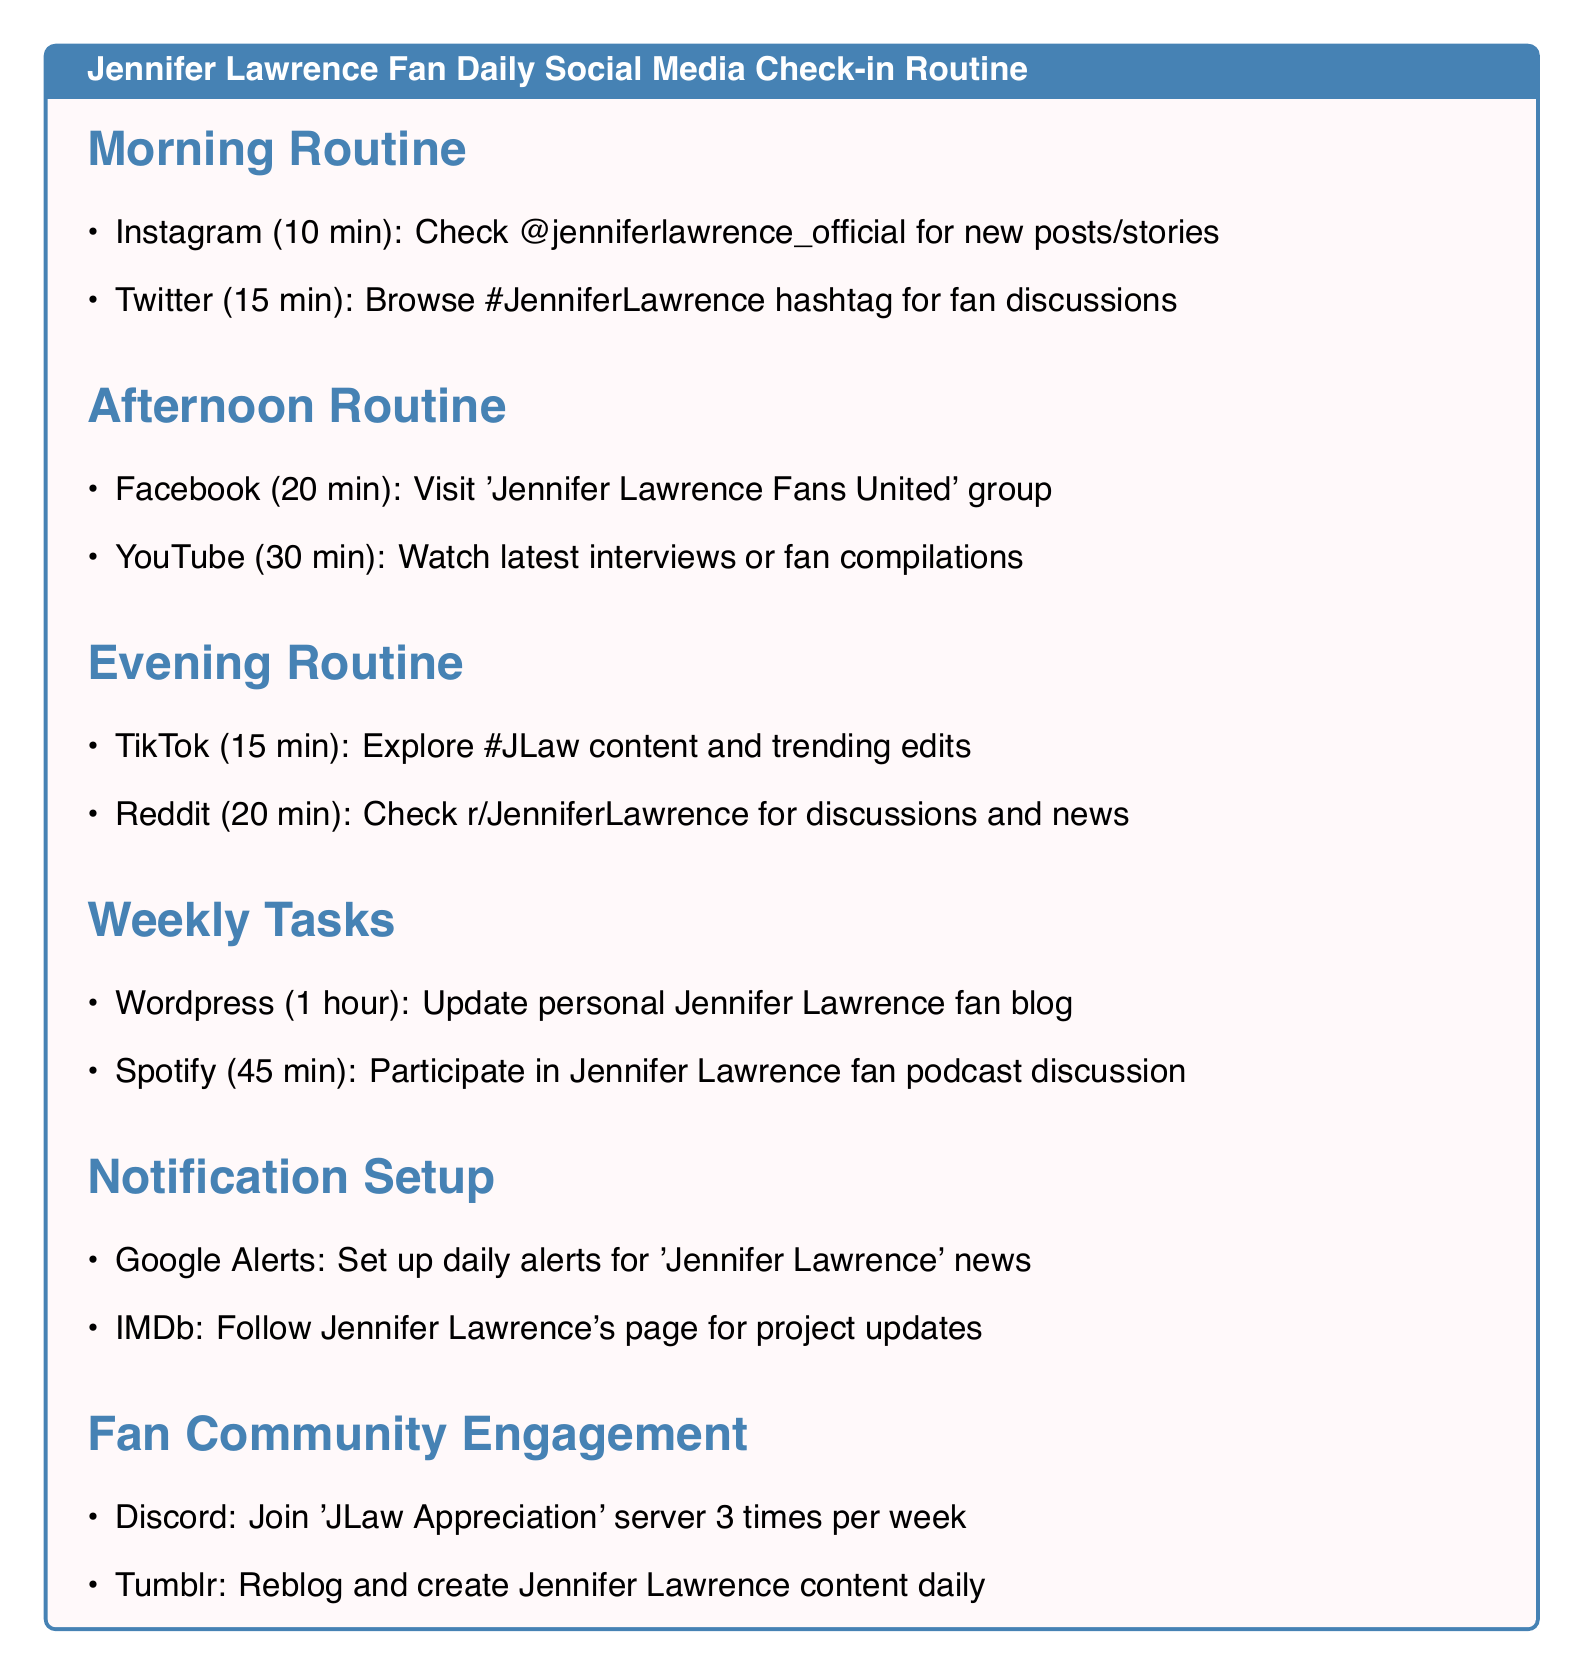what is the first platform checked in the morning routine? The document states that the first action in the morning routine is to check Instagram.
Answer: Instagram how many minutes are allocated to Twitter in the morning routine? The document lists 15 minutes for browsing Twitter in the morning routine.
Answer: 15 minutes which group on Facebook is recommended for updates? The document mentions visiting 'Jennifer Lawrence Fans United' group for updates.
Answer: 'Jennifer Lawrence Fans United' how long is spent watching content on YouTube in the afternoon routine? The afternoon routine specifies watching for 30 minutes on YouTube.
Answer: 30 minutes which social media platform is used to explore trending edits in the evening routine? The document indicates TikTok is used for exploring trending edits.
Answer: TikTok what is the total time spent on the afternoon routine? The afternoon routine consists of 20 minutes on Facebook and 30 minutes on YouTube, totaling 50 minutes.
Answer: 50 minutes how often should alerts be set up for 'Jennifer Lawrence' news articles? The document states these alerts should be set up daily.
Answer: Daily how many times a week is engagement on Discord suggested? The document indicates to join Discord 3 times per week.
Answer: 3 times per week what is the duration for updating the fan blog? The document specifies 1 hour for updating the personal fan blog on Wordpress.
Answer: 1 hour 